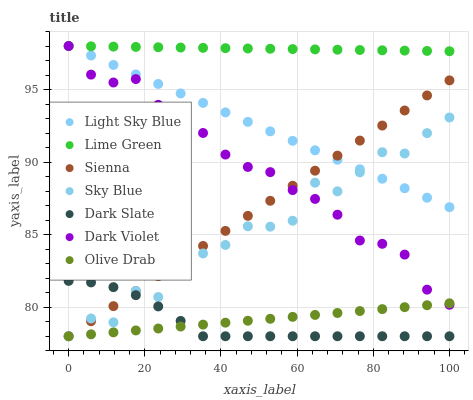Does Dark Slate have the minimum area under the curve?
Answer yes or no. Yes. Does Lime Green have the maximum area under the curve?
Answer yes or no. Yes. Does Sienna have the minimum area under the curve?
Answer yes or no. No. Does Sienna have the maximum area under the curve?
Answer yes or no. No. Is Olive Drab the smoothest?
Answer yes or no. Yes. Is Sky Blue the roughest?
Answer yes or no. Yes. Is Sienna the smoothest?
Answer yes or no. No. Is Sienna the roughest?
Answer yes or no. No. Does Sienna have the lowest value?
Answer yes or no. Yes. Does Light Sky Blue have the lowest value?
Answer yes or no. No. Does Lime Green have the highest value?
Answer yes or no. Yes. Does Sienna have the highest value?
Answer yes or no. No. Is Sienna less than Lime Green?
Answer yes or no. Yes. Is Lime Green greater than Sky Blue?
Answer yes or no. Yes. Does Lime Green intersect Dark Violet?
Answer yes or no. Yes. Is Lime Green less than Dark Violet?
Answer yes or no. No. Is Lime Green greater than Dark Violet?
Answer yes or no. No. Does Sienna intersect Lime Green?
Answer yes or no. No. 